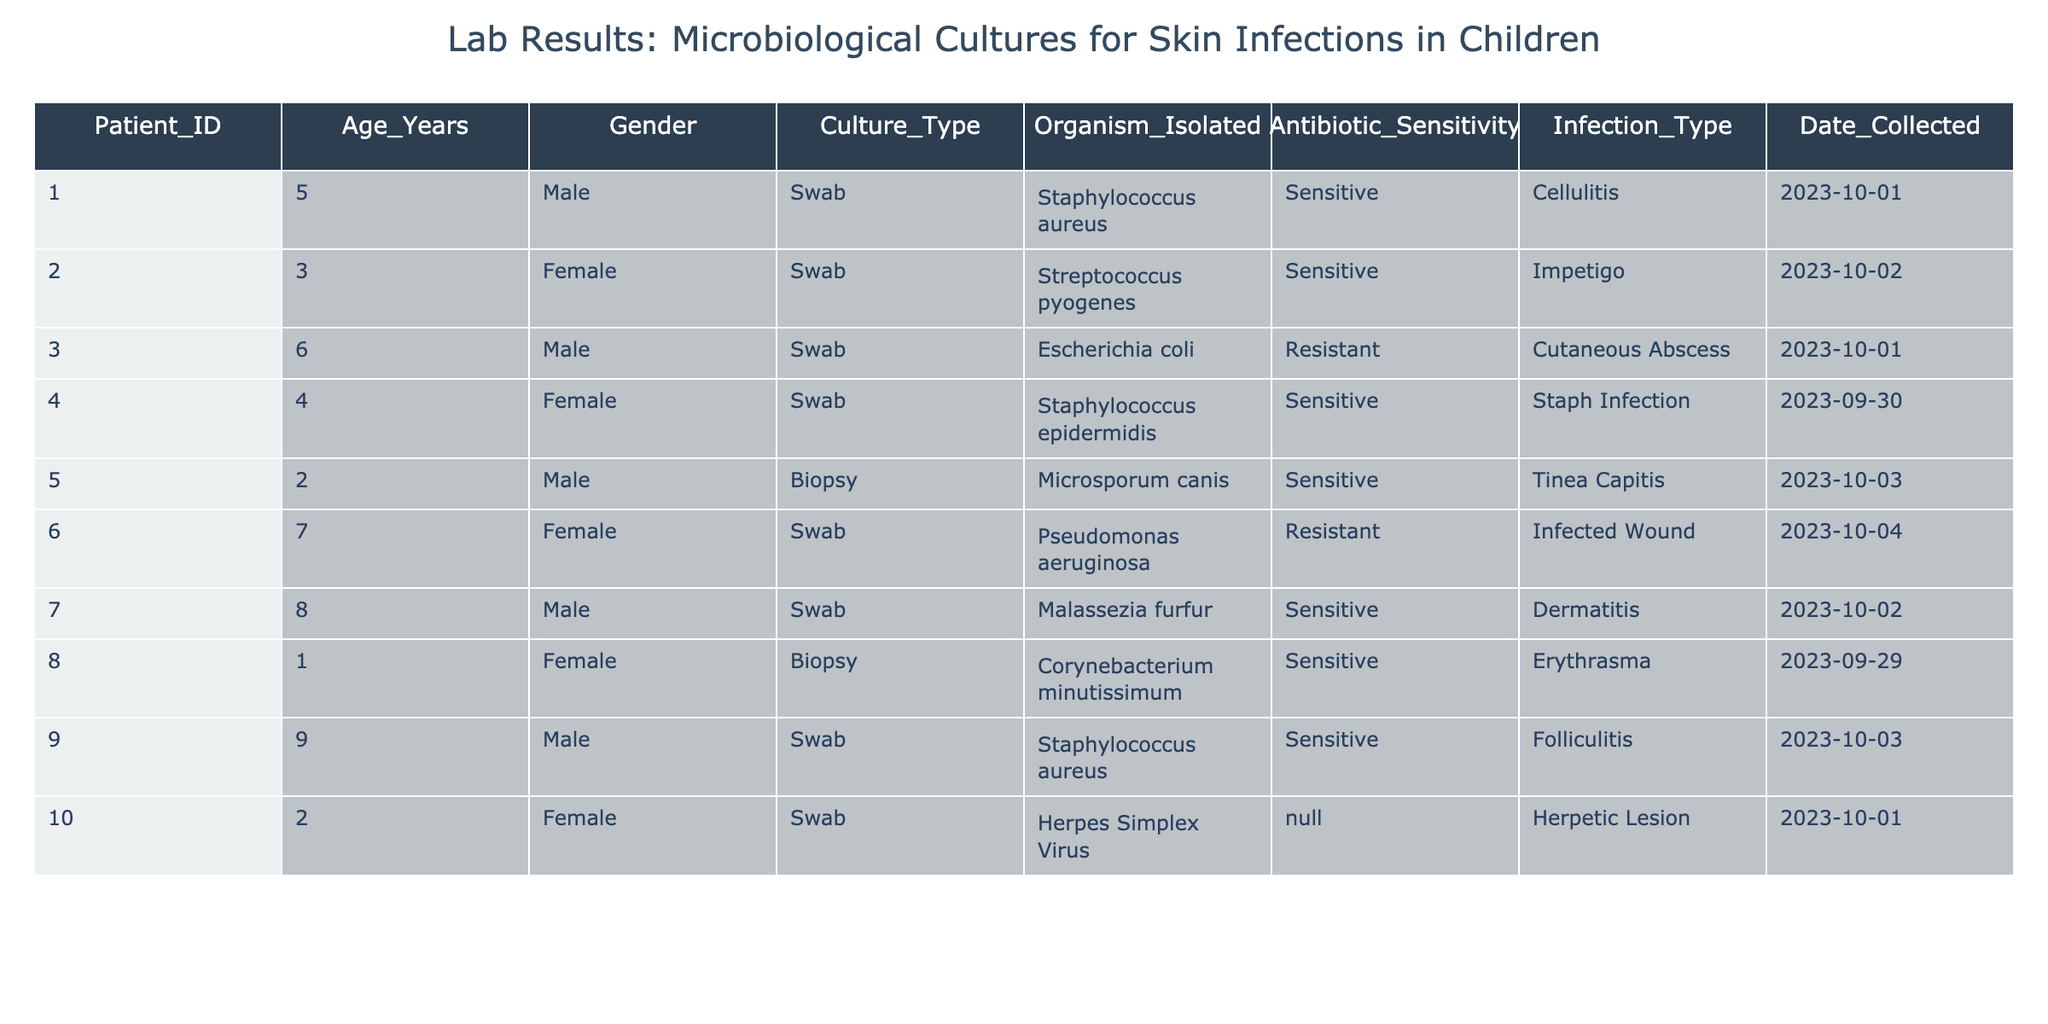What is the infection type for Patient 001? By looking at the table, I can find the entry for Patient 001. Under the "Infection_Type" column corresponding to Patient 001, it states "Cellulitis".
Answer: Cellulitis How many patients are male? To determine the number of male patients, I can count the entries in the "Gender" column tagged as "Male". There are four entries: Patient 001, 003, 007, and 009.
Answer: 4 Which organism isolated from Patient 006 is resistant to antibiotics? By checking the row for Patient 006, the "Organism_Isolated" column shows "Pseudomonas aeruginosa" and the "Antibiotic_Sensitivity" column indicates "Resistant". This confirms the organism's resistance.
Answer: Pseudomonas aeruginosa Is there any patient with Herpes Simplex Virus detected? I see in the table that under the "Organism_Isolated" column for Patient 010, "Herpes Simplex Virus" is listed. Thus, the statement is true.
Answer: Yes What is the average age of patients with a sensitive organism? First, I will identify the patients with "Sensitive" organisms, which includes 001, 002, 004, 005, 007, 008, and 009. Their ages are 5, 3, 4, 2, 8, 1, and 9, respectively. To calculate the average age, sum these ages (5 + 3 + 4 + 2 + 8 + 1 + 9 = 32) and divide by the number of patients (7). Thus, the average age is 32/7 = approximately 4.57.
Answer: 4.57 How many cultures were taken by swab compared to biopsy? There are a total of 8 entries identified as "Swab" (Patients 001, 002, 003, 004, 006, 007, 009, and 010) and 2 entries for "Biopsy" (Patients 005 and 008). The comparison shows that there are significantly more swabs.
Answer: 8 swabs, 2 biopsies What is the organisms isolated from the youngest patient? The youngest patient is Patient 008, who is 1 year old. Referring to the "Organism_Isolated" column for this patient, it shows "Corynebacterium minutissimum".
Answer: Corynebacterium minutissimum Have more than one organism been isolated with a sensitivity to antibiotics? In the table, I can compare the "Antibiotic_Sensitivity" column. There are seven patients with "Sensitive" organisms (Patients 001, 002, 004, 005, 007, 008, 009), confirming that multiple organisms are represented.
Answer: Yes 